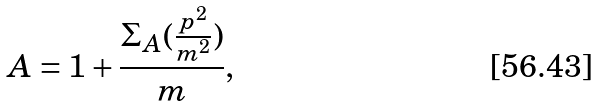<formula> <loc_0><loc_0><loc_500><loc_500>A = 1 + \frac { \Sigma _ { A } ( \frac { p ^ { 2 } } { m ^ { 2 } } ) } { m } ,</formula> 